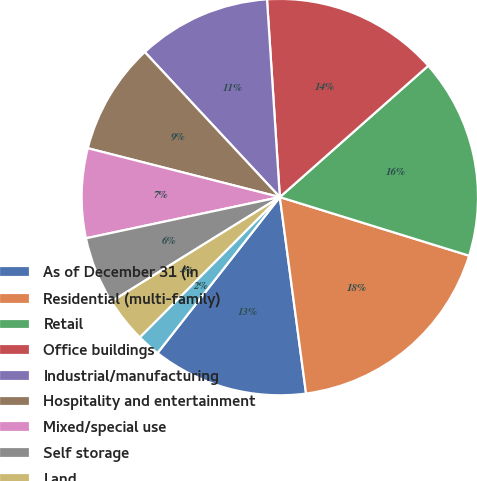Convert chart. <chart><loc_0><loc_0><loc_500><loc_500><pie_chart><fcel>As of December 31 (in<fcel>Residential (multi-family)<fcel>Retail<fcel>Office buildings<fcel>Industrial/manufacturing<fcel>Hospitality and entertainment<fcel>Mixed/special use<fcel>Self storage<fcel>Land<fcel>Health care<nl><fcel>12.7%<fcel>18.11%<fcel>16.31%<fcel>14.5%<fcel>10.9%<fcel>9.1%<fcel>7.3%<fcel>5.5%<fcel>3.69%<fcel>1.89%<nl></chart> 